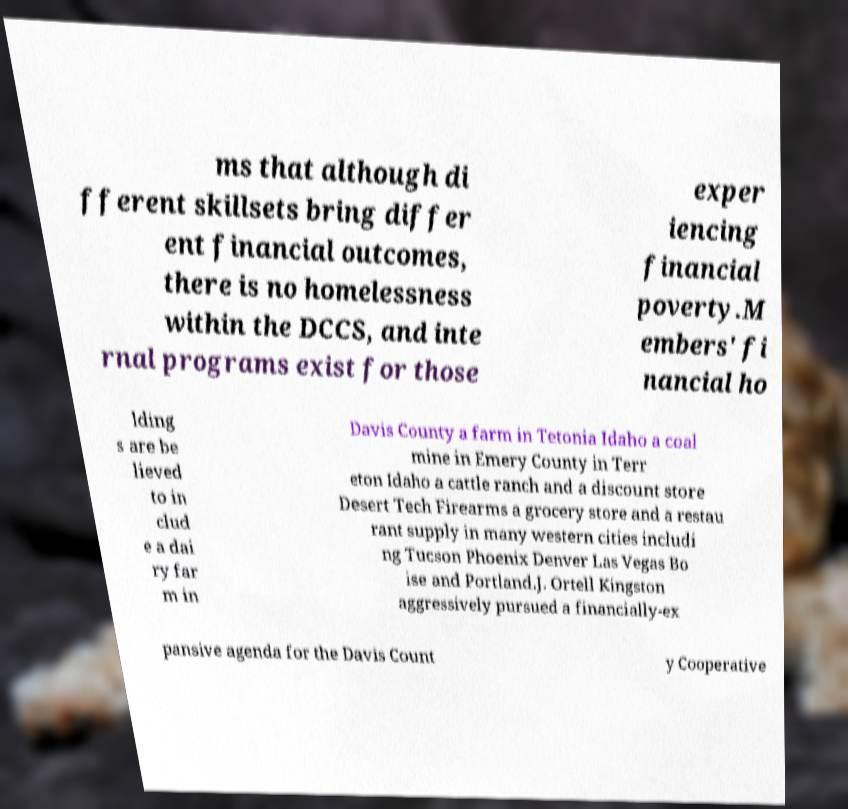Could you assist in decoding the text presented in this image and type it out clearly? ms that although di fferent skillsets bring differ ent financial outcomes, there is no homelessness within the DCCS, and inte rnal programs exist for those exper iencing financial poverty.M embers' fi nancial ho lding s are be lieved to in clud e a dai ry far m in Davis County a farm in Tetonia Idaho a coal mine in Emery County in Terr eton Idaho a cattle ranch and a discount store Desert Tech Firearms a grocery store and a restau rant supply in many western cities includi ng Tucson Phoenix Denver Las Vegas Bo ise and Portland.J. Ortell Kingston aggressively pursued a financially-ex pansive agenda for the Davis Count y Cooperative 